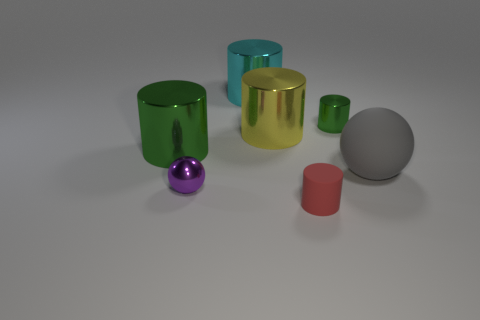There is another green object that is the same shape as the tiny green shiny thing; what material is it?
Give a very brief answer. Metal. There is another cylinder that is the same color as the tiny metal cylinder; what is it made of?
Your response must be concise. Metal. There is a tiny metal thing that is behind the matte object to the right of the small red cylinder; what number of red matte objects are in front of it?
Ensure brevity in your answer.  1. Is the number of big gray matte spheres that are on the right side of the big ball greater than the number of large things in front of the tiny rubber cylinder?
Make the answer very short. No. How many large objects are the same shape as the small red rubber thing?
Ensure brevity in your answer.  3. How many things are tiny cylinders that are behind the big gray object or objects that are on the right side of the metal sphere?
Your response must be concise. 5. What is the small green object that is right of the green metal object that is left of the large metal cylinder that is to the right of the large cyan cylinder made of?
Keep it short and to the point. Metal. Does the ball in front of the gray rubber object have the same color as the tiny rubber object?
Provide a short and direct response. No. What material is the big cylinder that is both in front of the big cyan shiny thing and on the right side of the small purple metallic object?
Ensure brevity in your answer.  Metal. Is there a yellow thing of the same size as the gray sphere?
Give a very brief answer. Yes. 